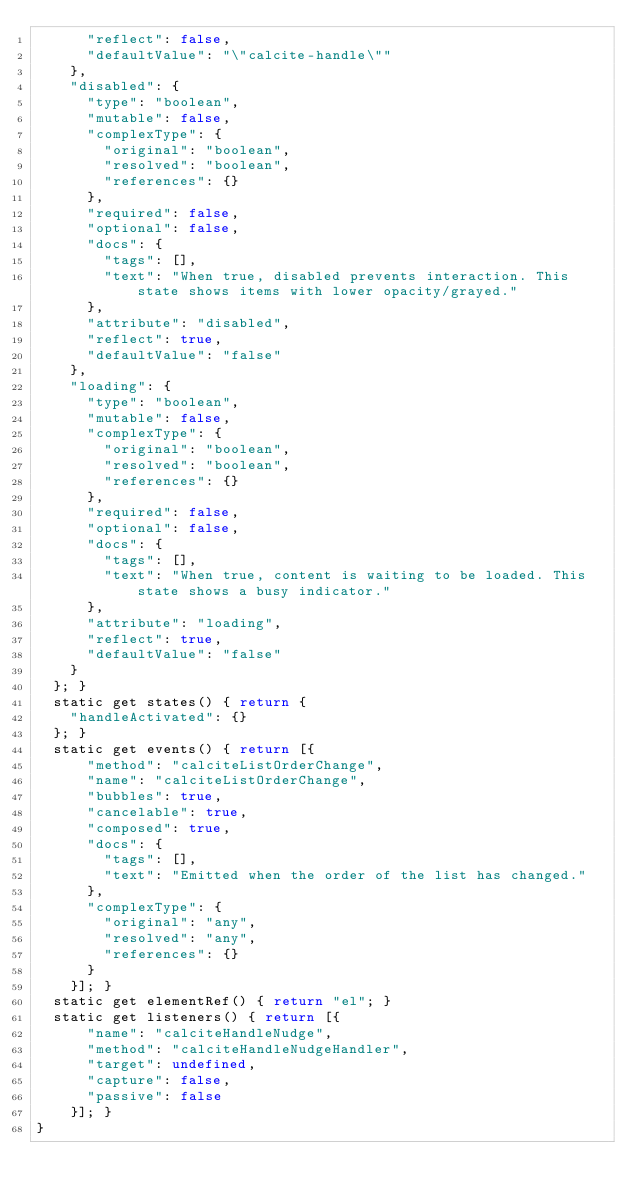Convert code to text. <code><loc_0><loc_0><loc_500><loc_500><_JavaScript_>      "reflect": false,
      "defaultValue": "\"calcite-handle\""
    },
    "disabled": {
      "type": "boolean",
      "mutable": false,
      "complexType": {
        "original": "boolean",
        "resolved": "boolean",
        "references": {}
      },
      "required": false,
      "optional": false,
      "docs": {
        "tags": [],
        "text": "When true, disabled prevents interaction. This state shows items with lower opacity/grayed."
      },
      "attribute": "disabled",
      "reflect": true,
      "defaultValue": "false"
    },
    "loading": {
      "type": "boolean",
      "mutable": false,
      "complexType": {
        "original": "boolean",
        "resolved": "boolean",
        "references": {}
      },
      "required": false,
      "optional": false,
      "docs": {
        "tags": [],
        "text": "When true, content is waiting to be loaded. This state shows a busy indicator."
      },
      "attribute": "loading",
      "reflect": true,
      "defaultValue": "false"
    }
  }; }
  static get states() { return {
    "handleActivated": {}
  }; }
  static get events() { return [{
      "method": "calciteListOrderChange",
      "name": "calciteListOrderChange",
      "bubbles": true,
      "cancelable": true,
      "composed": true,
      "docs": {
        "tags": [],
        "text": "Emitted when the order of the list has changed."
      },
      "complexType": {
        "original": "any",
        "resolved": "any",
        "references": {}
      }
    }]; }
  static get elementRef() { return "el"; }
  static get listeners() { return [{
      "name": "calciteHandleNudge",
      "method": "calciteHandleNudgeHandler",
      "target": undefined,
      "capture": false,
      "passive": false
    }]; }
}
</code> 